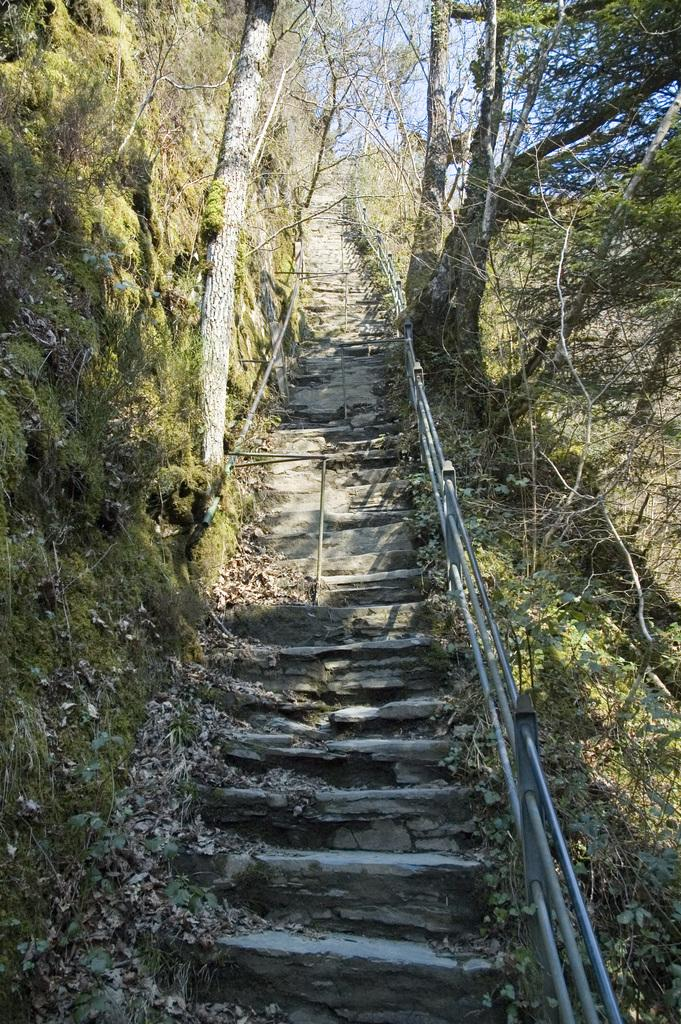What type of architectural feature can be seen in the image? There are steps in the image. What type of natural elements are present in the image? There are trees in the image. What can be seen in the background of the image? The sky is visible in the background of the image. What type of shirt is the crook wearing in the image? There is no crook or shirt present in the image. How does the health of the trees in the image compare to the health of trees in other images? There is no comparison to other images in this context, and the health of the trees cannot be determined without additional information. 